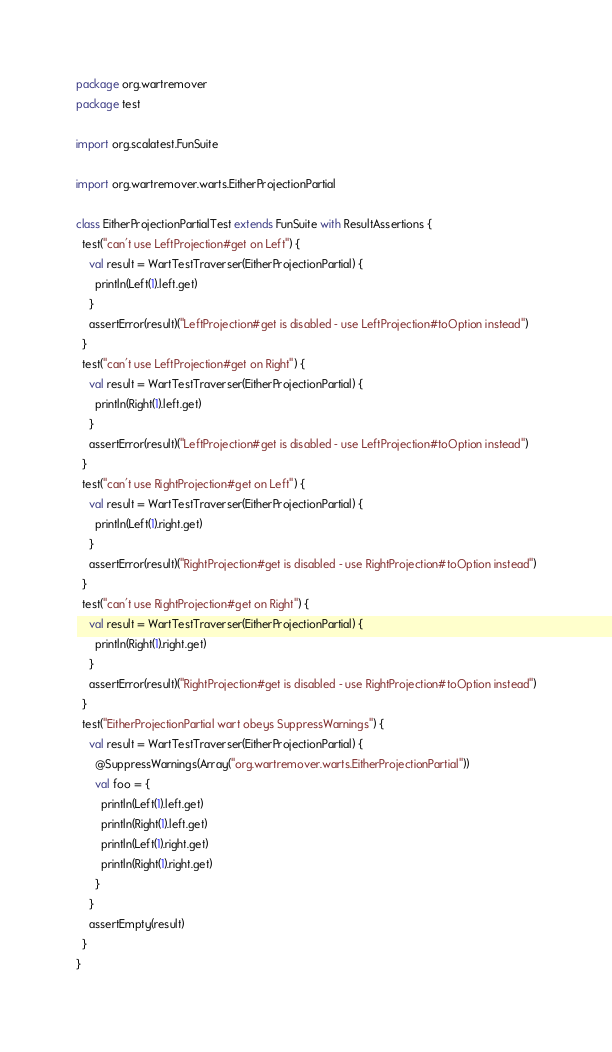Convert code to text. <code><loc_0><loc_0><loc_500><loc_500><_Scala_>package org.wartremover
package test

import org.scalatest.FunSuite

import org.wartremover.warts.EitherProjectionPartial

class EitherProjectionPartialTest extends FunSuite with ResultAssertions {
  test("can't use LeftProjection#get on Left") {
    val result = WartTestTraverser(EitherProjectionPartial) {
      println(Left(1).left.get)
    }
    assertError(result)("LeftProjection#get is disabled - use LeftProjection#toOption instead")
  }
  test("can't use LeftProjection#get on Right") {
    val result = WartTestTraverser(EitherProjectionPartial) {
      println(Right(1).left.get)
    }
    assertError(result)("LeftProjection#get is disabled - use LeftProjection#toOption instead")
  }
  test("can't use RightProjection#get on Left") {
    val result = WartTestTraverser(EitherProjectionPartial) {
      println(Left(1).right.get)
    }
    assertError(result)("RightProjection#get is disabled - use RightProjection#toOption instead")
  }
  test("can't use RightProjection#get on Right") {
    val result = WartTestTraverser(EitherProjectionPartial) {
      println(Right(1).right.get)
    }
    assertError(result)("RightProjection#get is disabled - use RightProjection#toOption instead")
  }
  test("EitherProjectionPartial wart obeys SuppressWarnings") {
    val result = WartTestTraverser(EitherProjectionPartial) {
      @SuppressWarnings(Array("org.wartremover.warts.EitherProjectionPartial"))
      val foo = {
        println(Left(1).left.get)
        println(Right(1).left.get)
        println(Left(1).right.get)
        println(Right(1).right.get)
      }
    }
    assertEmpty(result)
  }
}
</code> 